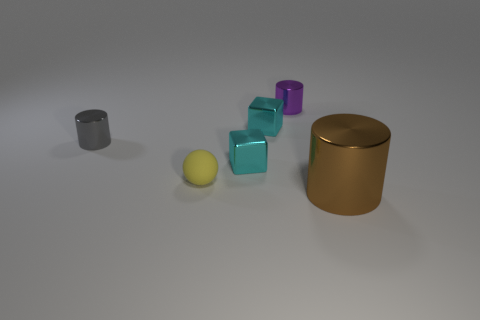The brown shiny object has what shape?
Your answer should be compact. Cylinder. What shape is the small purple object that is made of the same material as the big brown cylinder?
Ensure brevity in your answer.  Cylinder. The purple cylinder that is the same material as the tiny gray cylinder is what size?
Provide a short and direct response. Small. The tiny metal thing that is in front of the purple cylinder and behind the gray cylinder has what shape?
Offer a terse response. Cube. What is the size of the brown object that is in front of the cyan shiny thing behind the tiny gray metallic cylinder?
Keep it short and to the point. Large. What number of other objects are the same color as the big cylinder?
Offer a terse response. 0. What material is the yellow sphere?
Keep it short and to the point. Rubber. Are any gray rubber blocks visible?
Ensure brevity in your answer.  No. Are there the same number of metal things that are on the left side of the tiny gray cylinder and tiny brown metallic objects?
Ensure brevity in your answer.  Yes. Is there anything else that has the same material as the ball?
Your answer should be very brief. No. 